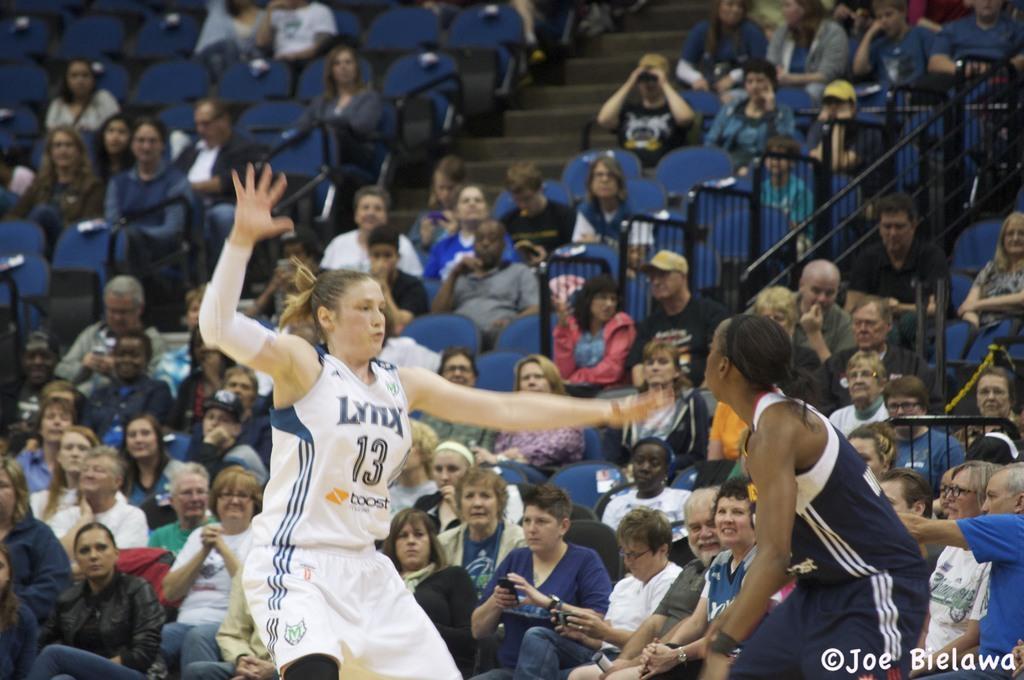Please provide a concise description of this image. This picture shows few people seated on the chairs and we see a woman jumping and another woman standing and we see text at the bottom right corner of the picture. 